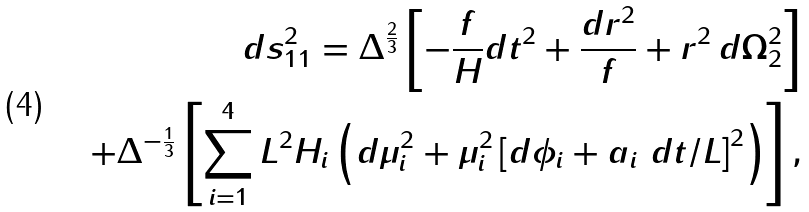Convert formula to latex. <formula><loc_0><loc_0><loc_500><loc_500>d s _ { 1 1 } ^ { 2 } = \Delta ^ { \frac { 2 } { 3 } } \left [ - \frac { f } { H } d t ^ { 2 } + \frac { d r ^ { 2 } } { f } + r ^ { 2 } \, d \Omega _ { 2 } ^ { 2 } \right ] \\ + \Delta ^ { - \frac { 1 } { 3 } } \left [ \sum _ { i = 1 } ^ { 4 } L ^ { 2 } H _ { i } \left ( d \mu _ { i } ^ { 2 } + \mu _ { i } ^ { 2 } \left [ d \phi _ { i } + a _ { i } \ d t / L \right ] ^ { 2 } \right ) \right ] ,</formula> 